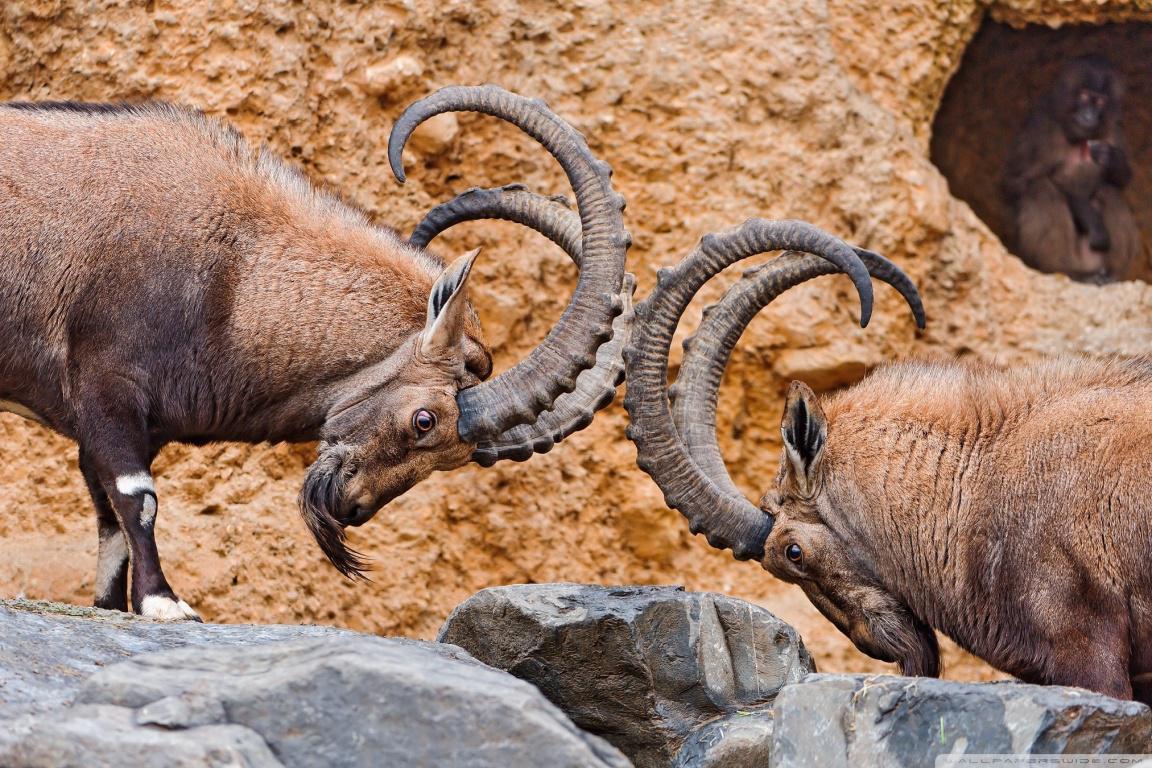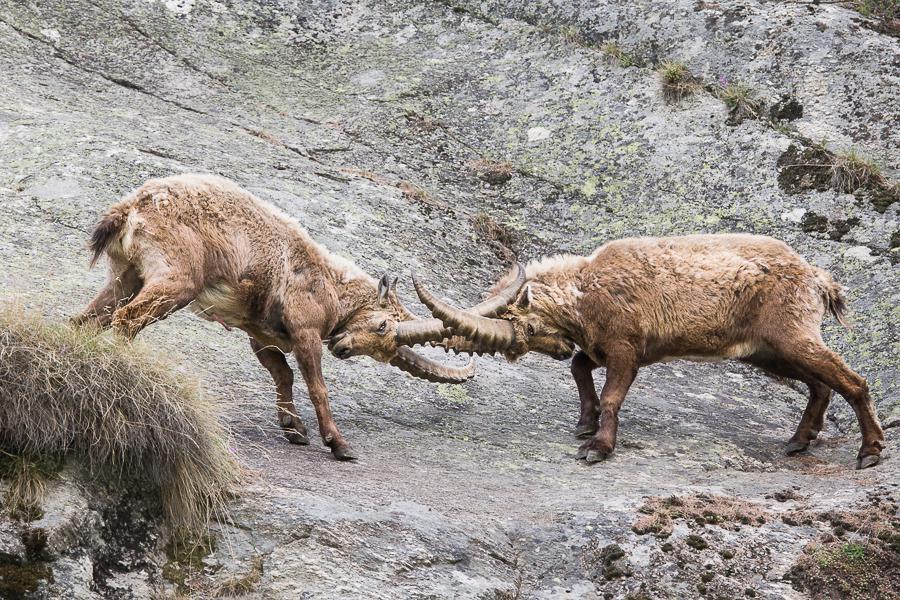The first image is the image on the left, the second image is the image on the right. Considering the images on both sides, is "The are two mountain goats on the left image." valid? Answer yes or no. Yes. The first image is the image on the left, the second image is the image on the right. Assess this claim about the two images: "A long horn sheep is laying on the ground". Correct or not? Answer yes or no. No. 